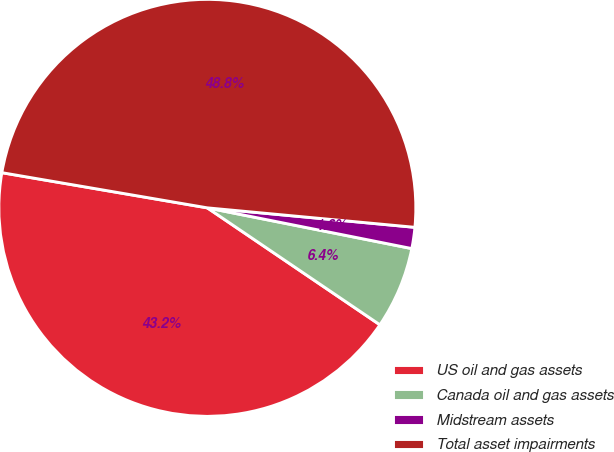<chart> <loc_0><loc_0><loc_500><loc_500><pie_chart><fcel>US oil and gas assets<fcel>Canada oil and gas assets<fcel>Midstream assets<fcel>Total asset impairments<nl><fcel>43.22%<fcel>6.35%<fcel>1.64%<fcel>48.79%<nl></chart> 